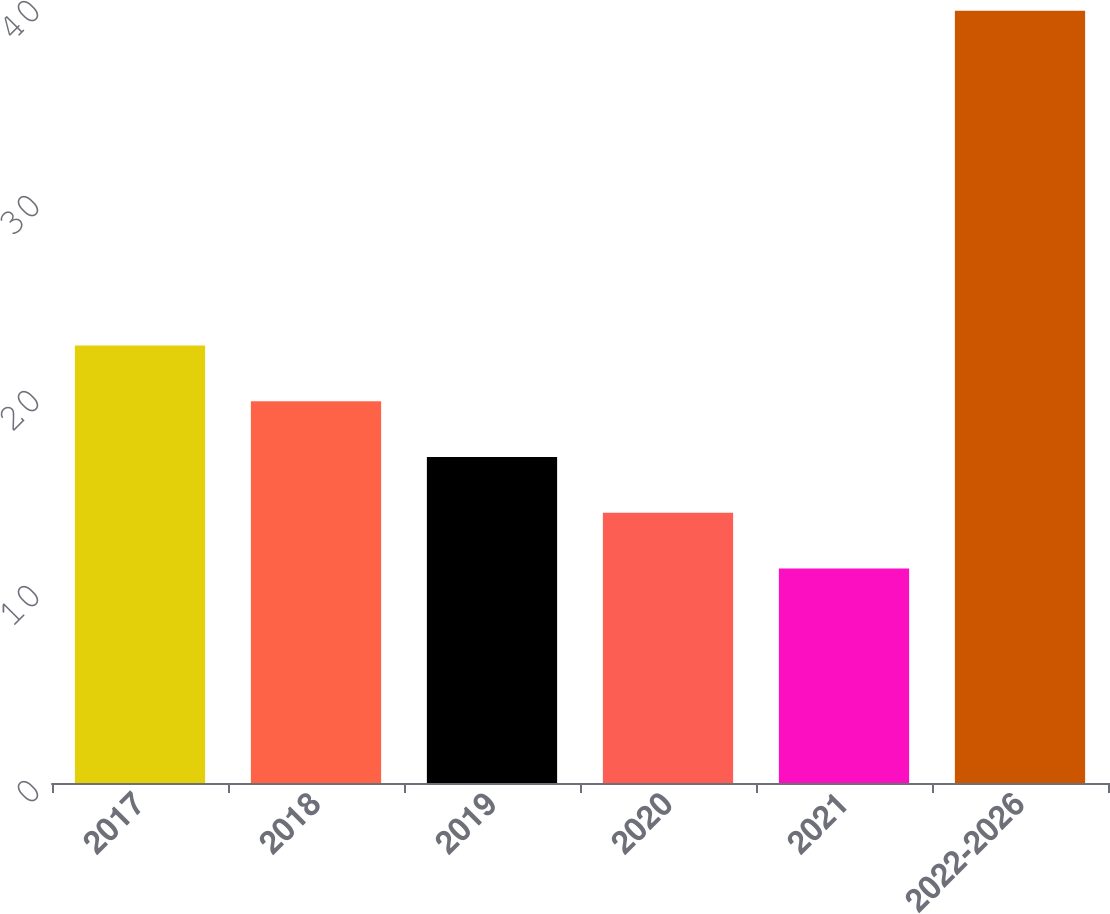Convert chart. <chart><loc_0><loc_0><loc_500><loc_500><bar_chart><fcel>2017<fcel>2018<fcel>2019<fcel>2020<fcel>2021<fcel>2022-2026<nl><fcel>22.44<fcel>19.58<fcel>16.72<fcel>13.86<fcel>11<fcel>39.6<nl></chart> 